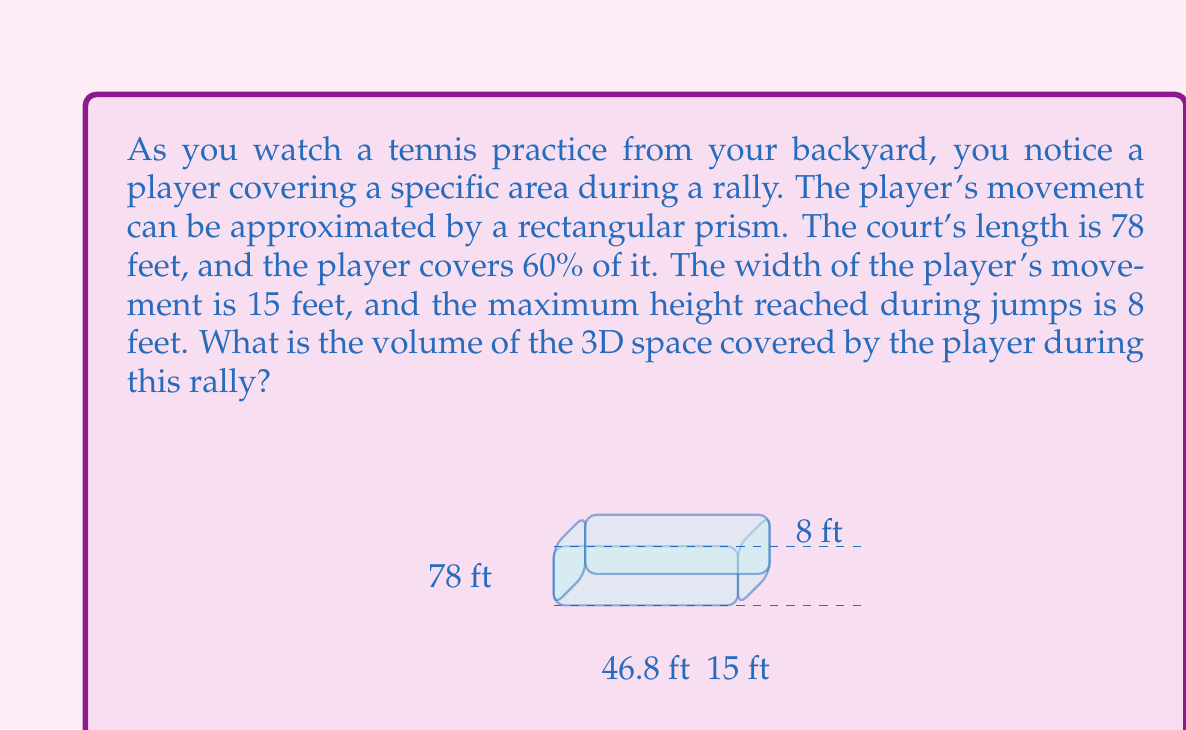Provide a solution to this math problem. To solve this problem, we need to follow these steps:

1) First, calculate the length of the space covered by the player:
   $$ \text{Length} = 78 \text{ feet} \times 60\% = 78 \times 0.6 = 46.8 \text{ feet} $$

2) We're given the width (15 feet) and height (8 feet) of the space.

3) The volume of a rectangular prism is calculated by multiplying length, width, and height:
   $$ V = l \times w \times h $$

4) Substitute the values:
   $$ V = 46.8 \text{ feet} \times 15 \text{ feet} \times 8 \text{ feet} $$

5) Calculate the result:
   $$ V = 5,616 \text{ cubic feet} $$

Therefore, the volume of the 3D space covered by the player during the rally is 5,616 cubic feet.
Answer: 5,616 cubic feet 